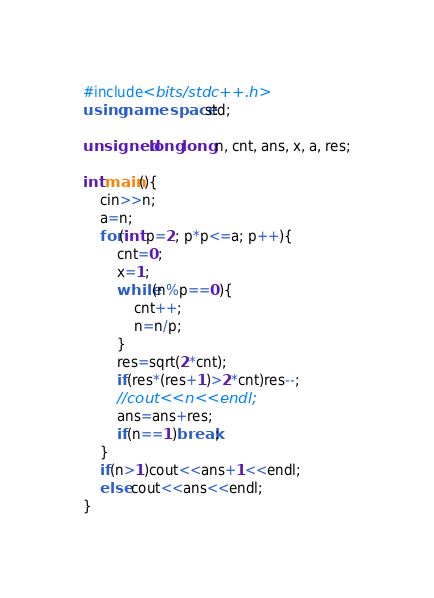Convert code to text. <code><loc_0><loc_0><loc_500><loc_500><_C++_>#include<bits/stdc++.h>
using namespace std;

unsigned long long n, cnt, ans, x, a, res;

int main(){
	cin>>n;
	a=n;
	for(int p=2; p*p<=a; p++){
		cnt=0;
		x=1;
		while(n%p==0){
			cnt++;
			n=n/p;
		}
		res=sqrt(2*cnt);
		if(res*(res+1)>2*cnt)res--;
		//cout<<n<<endl;
		ans=ans+res;
		if(n==1)break;
	}
	if(n>1)cout<<ans+1<<endl;
	else cout<<ans<<endl;
}
</code> 